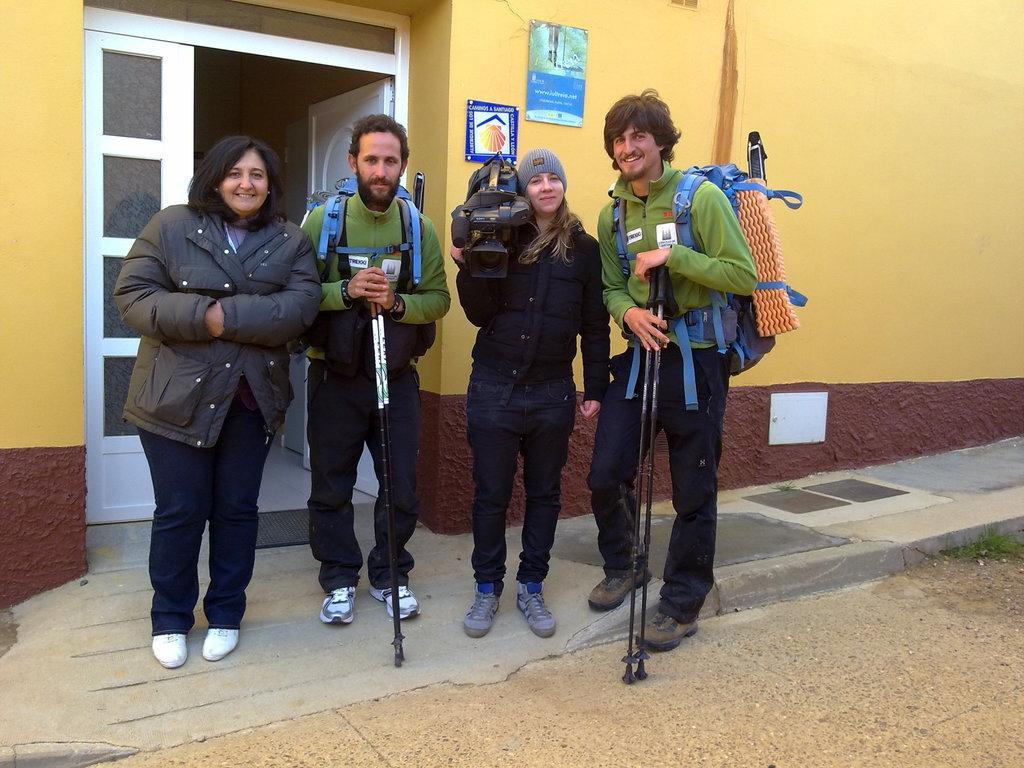Could you give a brief overview of what you see in this image? In this picture we can see four people smiling, standing on the ground, two men are carrying bags, holding sticks with their hands and a woman holding a camera with her hand. In the background we can see posts on the wall and doors. 